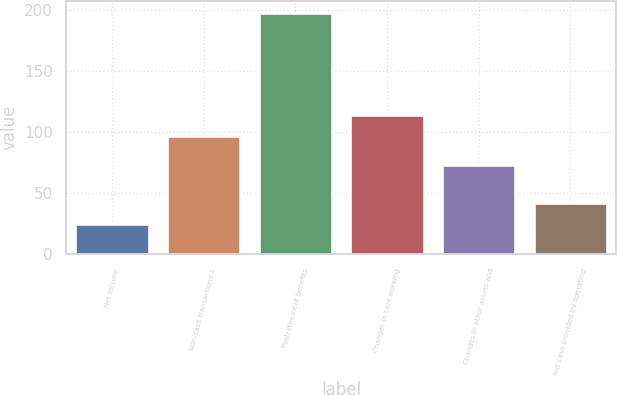Convert chart. <chart><loc_0><loc_0><loc_500><loc_500><bar_chart><fcel>Net income<fcel>Non-cash transactions 1<fcel>Postretirement benefits<fcel>Changes in core working<fcel>Changes in other assets and<fcel>Net cash provided by operating<nl><fcel>25<fcel>97<fcel>197<fcel>114.2<fcel>73<fcel>42.2<nl></chart> 